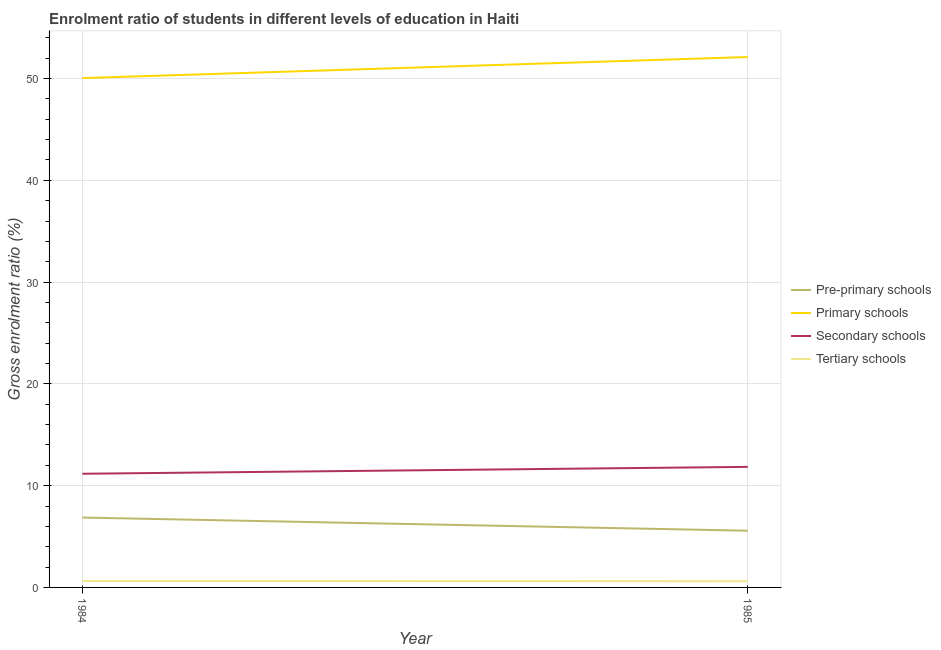How many different coloured lines are there?
Make the answer very short. 4. Does the line corresponding to gross enrolment ratio in pre-primary schools intersect with the line corresponding to gross enrolment ratio in primary schools?
Ensure brevity in your answer.  No. Is the number of lines equal to the number of legend labels?
Offer a terse response. Yes. What is the gross enrolment ratio in secondary schools in 1984?
Give a very brief answer. 11.17. Across all years, what is the maximum gross enrolment ratio in pre-primary schools?
Offer a terse response. 6.87. Across all years, what is the minimum gross enrolment ratio in pre-primary schools?
Your answer should be very brief. 5.57. What is the total gross enrolment ratio in pre-primary schools in the graph?
Offer a terse response. 12.44. What is the difference between the gross enrolment ratio in pre-primary schools in 1984 and that in 1985?
Offer a very short reply. 1.29. What is the difference between the gross enrolment ratio in secondary schools in 1984 and the gross enrolment ratio in primary schools in 1985?
Your answer should be compact. -40.94. What is the average gross enrolment ratio in tertiary schools per year?
Provide a succinct answer. 0.62. In the year 1984, what is the difference between the gross enrolment ratio in tertiary schools and gross enrolment ratio in primary schools?
Your answer should be compact. -49.41. In how many years, is the gross enrolment ratio in pre-primary schools greater than 2 %?
Your response must be concise. 2. What is the ratio of the gross enrolment ratio in secondary schools in 1984 to that in 1985?
Make the answer very short. 0.94. Is the gross enrolment ratio in secondary schools in 1984 less than that in 1985?
Make the answer very short. Yes. Is it the case that in every year, the sum of the gross enrolment ratio in secondary schools and gross enrolment ratio in tertiary schools is greater than the sum of gross enrolment ratio in primary schools and gross enrolment ratio in pre-primary schools?
Make the answer very short. No. Is it the case that in every year, the sum of the gross enrolment ratio in pre-primary schools and gross enrolment ratio in primary schools is greater than the gross enrolment ratio in secondary schools?
Your answer should be compact. Yes. Is the gross enrolment ratio in tertiary schools strictly greater than the gross enrolment ratio in secondary schools over the years?
Make the answer very short. No. Is the gross enrolment ratio in tertiary schools strictly less than the gross enrolment ratio in primary schools over the years?
Offer a terse response. Yes. How many lines are there?
Provide a succinct answer. 4. How many years are there in the graph?
Offer a terse response. 2. Are the values on the major ticks of Y-axis written in scientific E-notation?
Provide a succinct answer. No. How are the legend labels stacked?
Give a very brief answer. Vertical. What is the title of the graph?
Provide a short and direct response. Enrolment ratio of students in different levels of education in Haiti. Does "Financial sector" appear as one of the legend labels in the graph?
Keep it short and to the point. No. What is the label or title of the X-axis?
Your response must be concise. Year. What is the label or title of the Y-axis?
Provide a short and direct response. Gross enrolment ratio (%). What is the Gross enrolment ratio (%) of Pre-primary schools in 1984?
Your response must be concise. 6.87. What is the Gross enrolment ratio (%) in Primary schools in 1984?
Give a very brief answer. 50.04. What is the Gross enrolment ratio (%) in Secondary schools in 1984?
Provide a short and direct response. 11.17. What is the Gross enrolment ratio (%) of Tertiary schools in 1984?
Make the answer very short. 0.63. What is the Gross enrolment ratio (%) of Pre-primary schools in 1985?
Keep it short and to the point. 5.57. What is the Gross enrolment ratio (%) in Primary schools in 1985?
Offer a terse response. 52.11. What is the Gross enrolment ratio (%) of Secondary schools in 1985?
Offer a terse response. 11.84. What is the Gross enrolment ratio (%) in Tertiary schools in 1985?
Your answer should be very brief. 0.61. Across all years, what is the maximum Gross enrolment ratio (%) of Pre-primary schools?
Ensure brevity in your answer.  6.87. Across all years, what is the maximum Gross enrolment ratio (%) in Primary schools?
Provide a succinct answer. 52.11. Across all years, what is the maximum Gross enrolment ratio (%) in Secondary schools?
Ensure brevity in your answer.  11.84. Across all years, what is the maximum Gross enrolment ratio (%) of Tertiary schools?
Offer a very short reply. 0.63. Across all years, what is the minimum Gross enrolment ratio (%) in Pre-primary schools?
Provide a short and direct response. 5.57. Across all years, what is the minimum Gross enrolment ratio (%) of Primary schools?
Your response must be concise. 50.04. Across all years, what is the minimum Gross enrolment ratio (%) of Secondary schools?
Keep it short and to the point. 11.17. Across all years, what is the minimum Gross enrolment ratio (%) in Tertiary schools?
Keep it short and to the point. 0.61. What is the total Gross enrolment ratio (%) in Pre-primary schools in the graph?
Keep it short and to the point. 12.44. What is the total Gross enrolment ratio (%) of Primary schools in the graph?
Your answer should be very brief. 102.16. What is the total Gross enrolment ratio (%) of Secondary schools in the graph?
Your answer should be compact. 23.01. What is the total Gross enrolment ratio (%) in Tertiary schools in the graph?
Ensure brevity in your answer.  1.24. What is the difference between the Gross enrolment ratio (%) in Pre-primary schools in 1984 and that in 1985?
Offer a terse response. 1.29. What is the difference between the Gross enrolment ratio (%) in Primary schools in 1984 and that in 1985?
Give a very brief answer. -2.07. What is the difference between the Gross enrolment ratio (%) in Secondary schools in 1984 and that in 1985?
Provide a short and direct response. -0.68. What is the difference between the Gross enrolment ratio (%) in Tertiary schools in 1984 and that in 1985?
Your answer should be compact. 0.03. What is the difference between the Gross enrolment ratio (%) of Pre-primary schools in 1984 and the Gross enrolment ratio (%) of Primary schools in 1985?
Provide a short and direct response. -45.25. What is the difference between the Gross enrolment ratio (%) of Pre-primary schools in 1984 and the Gross enrolment ratio (%) of Secondary schools in 1985?
Your response must be concise. -4.98. What is the difference between the Gross enrolment ratio (%) in Pre-primary schools in 1984 and the Gross enrolment ratio (%) in Tertiary schools in 1985?
Your answer should be compact. 6.26. What is the difference between the Gross enrolment ratio (%) of Primary schools in 1984 and the Gross enrolment ratio (%) of Secondary schools in 1985?
Keep it short and to the point. 38.2. What is the difference between the Gross enrolment ratio (%) in Primary schools in 1984 and the Gross enrolment ratio (%) in Tertiary schools in 1985?
Your answer should be very brief. 49.44. What is the difference between the Gross enrolment ratio (%) in Secondary schools in 1984 and the Gross enrolment ratio (%) in Tertiary schools in 1985?
Offer a terse response. 10.56. What is the average Gross enrolment ratio (%) of Pre-primary schools per year?
Keep it short and to the point. 6.22. What is the average Gross enrolment ratio (%) in Primary schools per year?
Ensure brevity in your answer.  51.08. What is the average Gross enrolment ratio (%) of Secondary schools per year?
Offer a very short reply. 11.51. What is the average Gross enrolment ratio (%) in Tertiary schools per year?
Ensure brevity in your answer.  0.62. In the year 1984, what is the difference between the Gross enrolment ratio (%) in Pre-primary schools and Gross enrolment ratio (%) in Primary schools?
Your answer should be very brief. -43.18. In the year 1984, what is the difference between the Gross enrolment ratio (%) of Pre-primary schools and Gross enrolment ratio (%) of Secondary schools?
Your response must be concise. -4.3. In the year 1984, what is the difference between the Gross enrolment ratio (%) in Pre-primary schools and Gross enrolment ratio (%) in Tertiary schools?
Keep it short and to the point. 6.23. In the year 1984, what is the difference between the Gross enrolment ratio (%) in Primary schools and Gross enrolment ratio (%) in Secondary schools?
Make the answer very short. 38.88. In the year 1984, what is the difference between the Gross enrolment ratio (%) in Primary schools and Gross enrolment ratio (%) in Tertiary schools?
Provide a short and direct response. 49.41. In the year 1984, what is the difference between the Gross enrolment ratio (%) in Secondary schools and Gross enrolment ratio (%) in Tertiary schools?
Give a very brief answer. 10.53. In the year 1985, what is the difference between the Gross enrolment ratio (%) in Pre-primary schools and Gross enrolment ratio (%) in Primary schools?
Provide a short and direct response. -46.54. In the year 1985, what is the difference between the Gross enrolment ratio (%) of Pre-primary schools and Gross enrolment ratio (%) of Secondary schools?
Give a very brief answer. -6.27. In the year 1985, what is the difference between the Gross enrolment ratio (%) of Pre-primary schools and Gross enrolment ratio (%) of Tertiary schools?
Your answer should be very brief. 4.97. In the year 1985, what is the difference between the Gross enrolment ratio (%) in Primary schools and Gross enrolment ratio (%) in Secondary schools?
Offer a very short reply. 40.27. In the year 1985, what is the difference between the Gross enrolment ratio (%) in Primary schools and Gross enrolment ratio (%) in Tertiary schools?
Offer a terse response. 51.51. In the year 1985, what is the difference between the Gross enrolment ratio (%) of Secondary schools and Gross enrolment ratio (%) of Tertiary schools?
Offer a terse response. 11.24. What is the ratio of the Gross enrolment ratio (%) of Pre-primary schools in 1984 to that in 1985?
Offer a terse response. 1.23. What is the ratio of the Gross enrolment ratio (%) of Primary schools in 1984 to that in 1985?
Your answer should be very brief. 0.96. What is the ratio of the Gross enrolment ratio (%) in Secondary schools in 1984 to that in 1985?
Ensure brevity in your answer.  0.94. What is the ratio of the Gross enrolment ratio (%) of Tertiary schools in 1984 to that in 1985?
Ensure brevity in your answer.  1.05. What is the difference between the highest and the second highest Gross enrolment ratio (%) of Pre-primary schools?
Ensure brevity in your answer.  1.29. What is the difference between the highest and the second highest Gross enrolment ratio (%) in Primary schools?
Your response must be concise. 2.07. What is the difference between the highest and the second highest Gross enrolment ratio (%) of Secondary schools?
Keep it short and to the point. 0.68. What is the difference between the highest and the second highest Gross enrolment ratio (%) of Tertiary schools?
Make the answer very short. 0.03. What is the difference between the highest and the lowest Gross enrolment ratio (%) in Pre-primary schools?
Keep it short and to the point. 1.29. What is the difference between the highest and the lowest Gross enrolment ratio (%) of Primary schools?
Make the answer very short. 2.07. What is the difference between the highest and the lowest Gross enrolment ratio (%) of Secondary schools?
Ensure brevity in your answer.  0.68. What is the difference between the highest and the lowest Gross enrolment ratio (%) in Tertiary schools?
Your answer should be very brief. 0.03. 